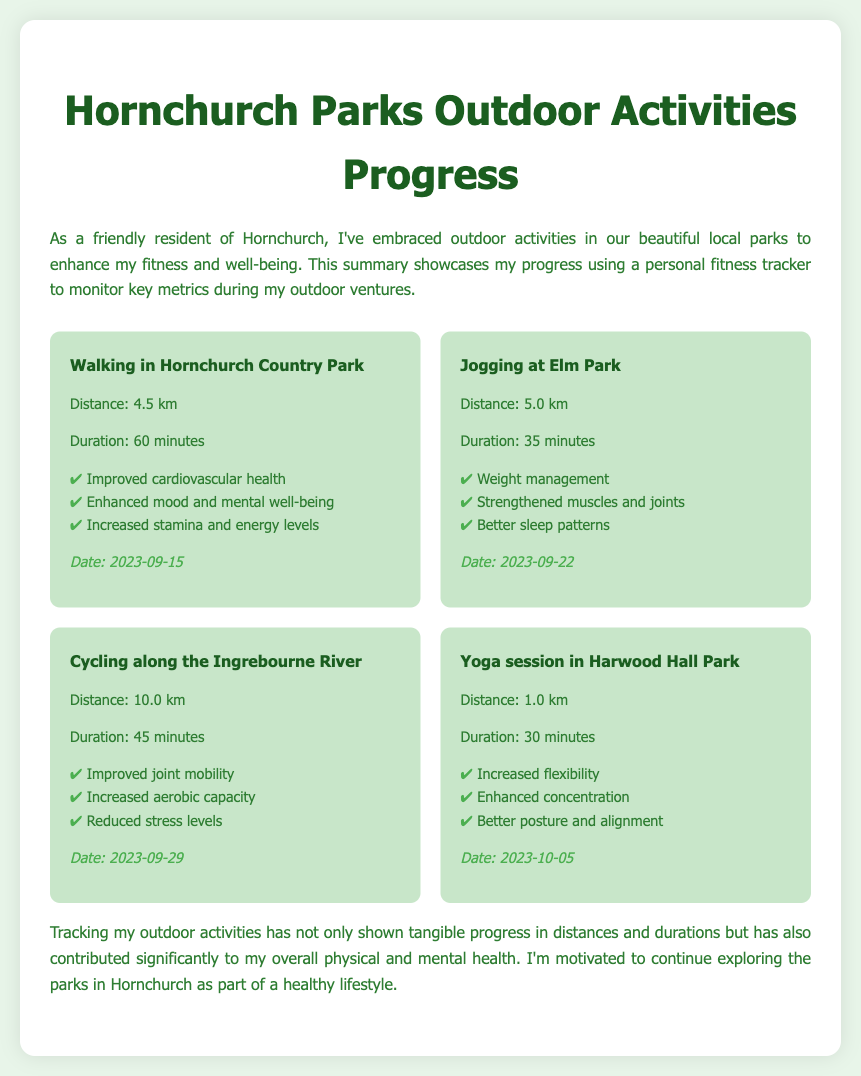What is the distance covered while walking in Hornchurch Country Park? The distance covered during the activity is provided in the document as 4.5 km.
Answer: 4.5 km What was the duration of the jogging session at Elm Park? The duration of the jogging session is specified in the document as 35 minutes.
Answer: 35 minutes Which activity contributed to improved joint mobility? The document lists cycling along the Ingrebourne River as the activity that contributes to improved joint mobility.
Answer: Cycling along the Ingrebourne River What is one health benefit of yoga in Harwood Hall Park? The document mentions several health benefits of yoga, with one being increased flexibility.
Answer: Increased flexibility On what date was the walking activity in Hornchurch Country Park performed? The specific date for the walking activity is provided as 2023-09-15 in the document.
Answer: 2023-09-15 What is the total distance covered during cycling? The total distance for the cycling activity is mentioned as 10.0 km in the document.
Answer: 10.0 km How many minutes did the yoga session last? The document indicates that the yoga session lasted for 30 minutes.
Answer: 30 minutes What health benefit is linked to better sleep patterns? The document states that jogging at Elm Park is linked with better sleep patterns as one of its health benefits.
Answer: Jogging at Elm Park Which location is mentioned for the cycling activity? The cycling activity took place along the Ingrebourne River, as noted in the document.
Answer: Ingrebourne River 